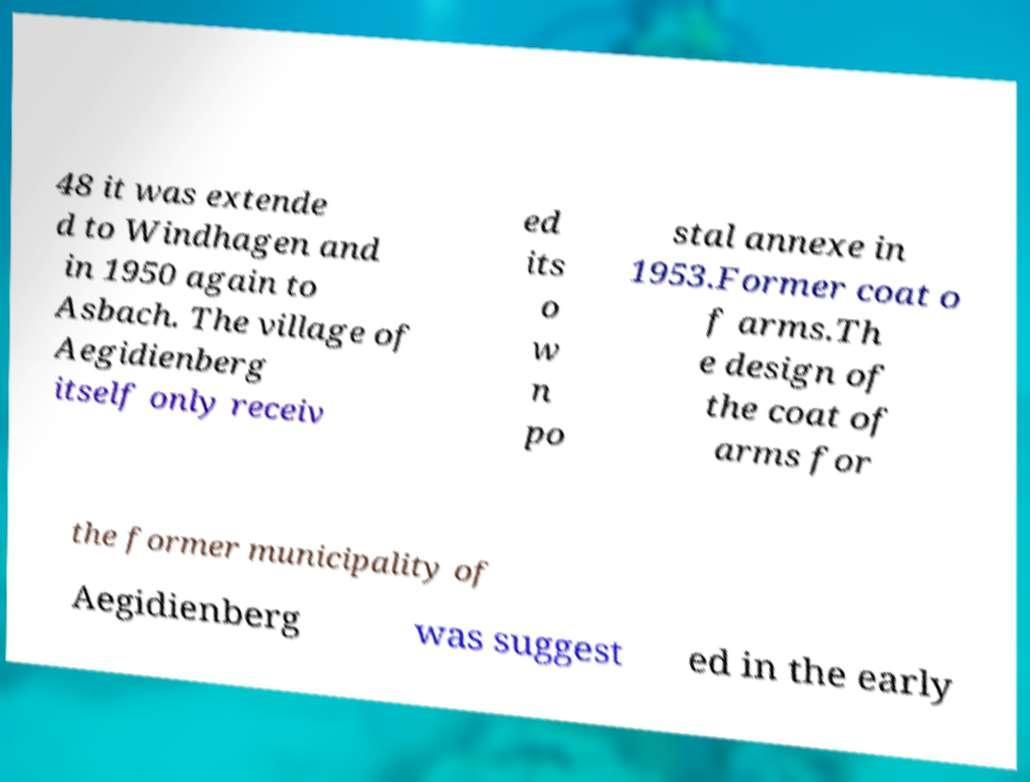Could you extract and type out the text from this image? 48 it was extende d to Windhagen and in 1950 again to Asbach. The village of Aegidienberg itself only receiv ed its o w n po stal annexe in 1953.Former coat o f arms.Th e design of the coat of arms for the former municipality of Aegidienberg was suggest ed in the early 